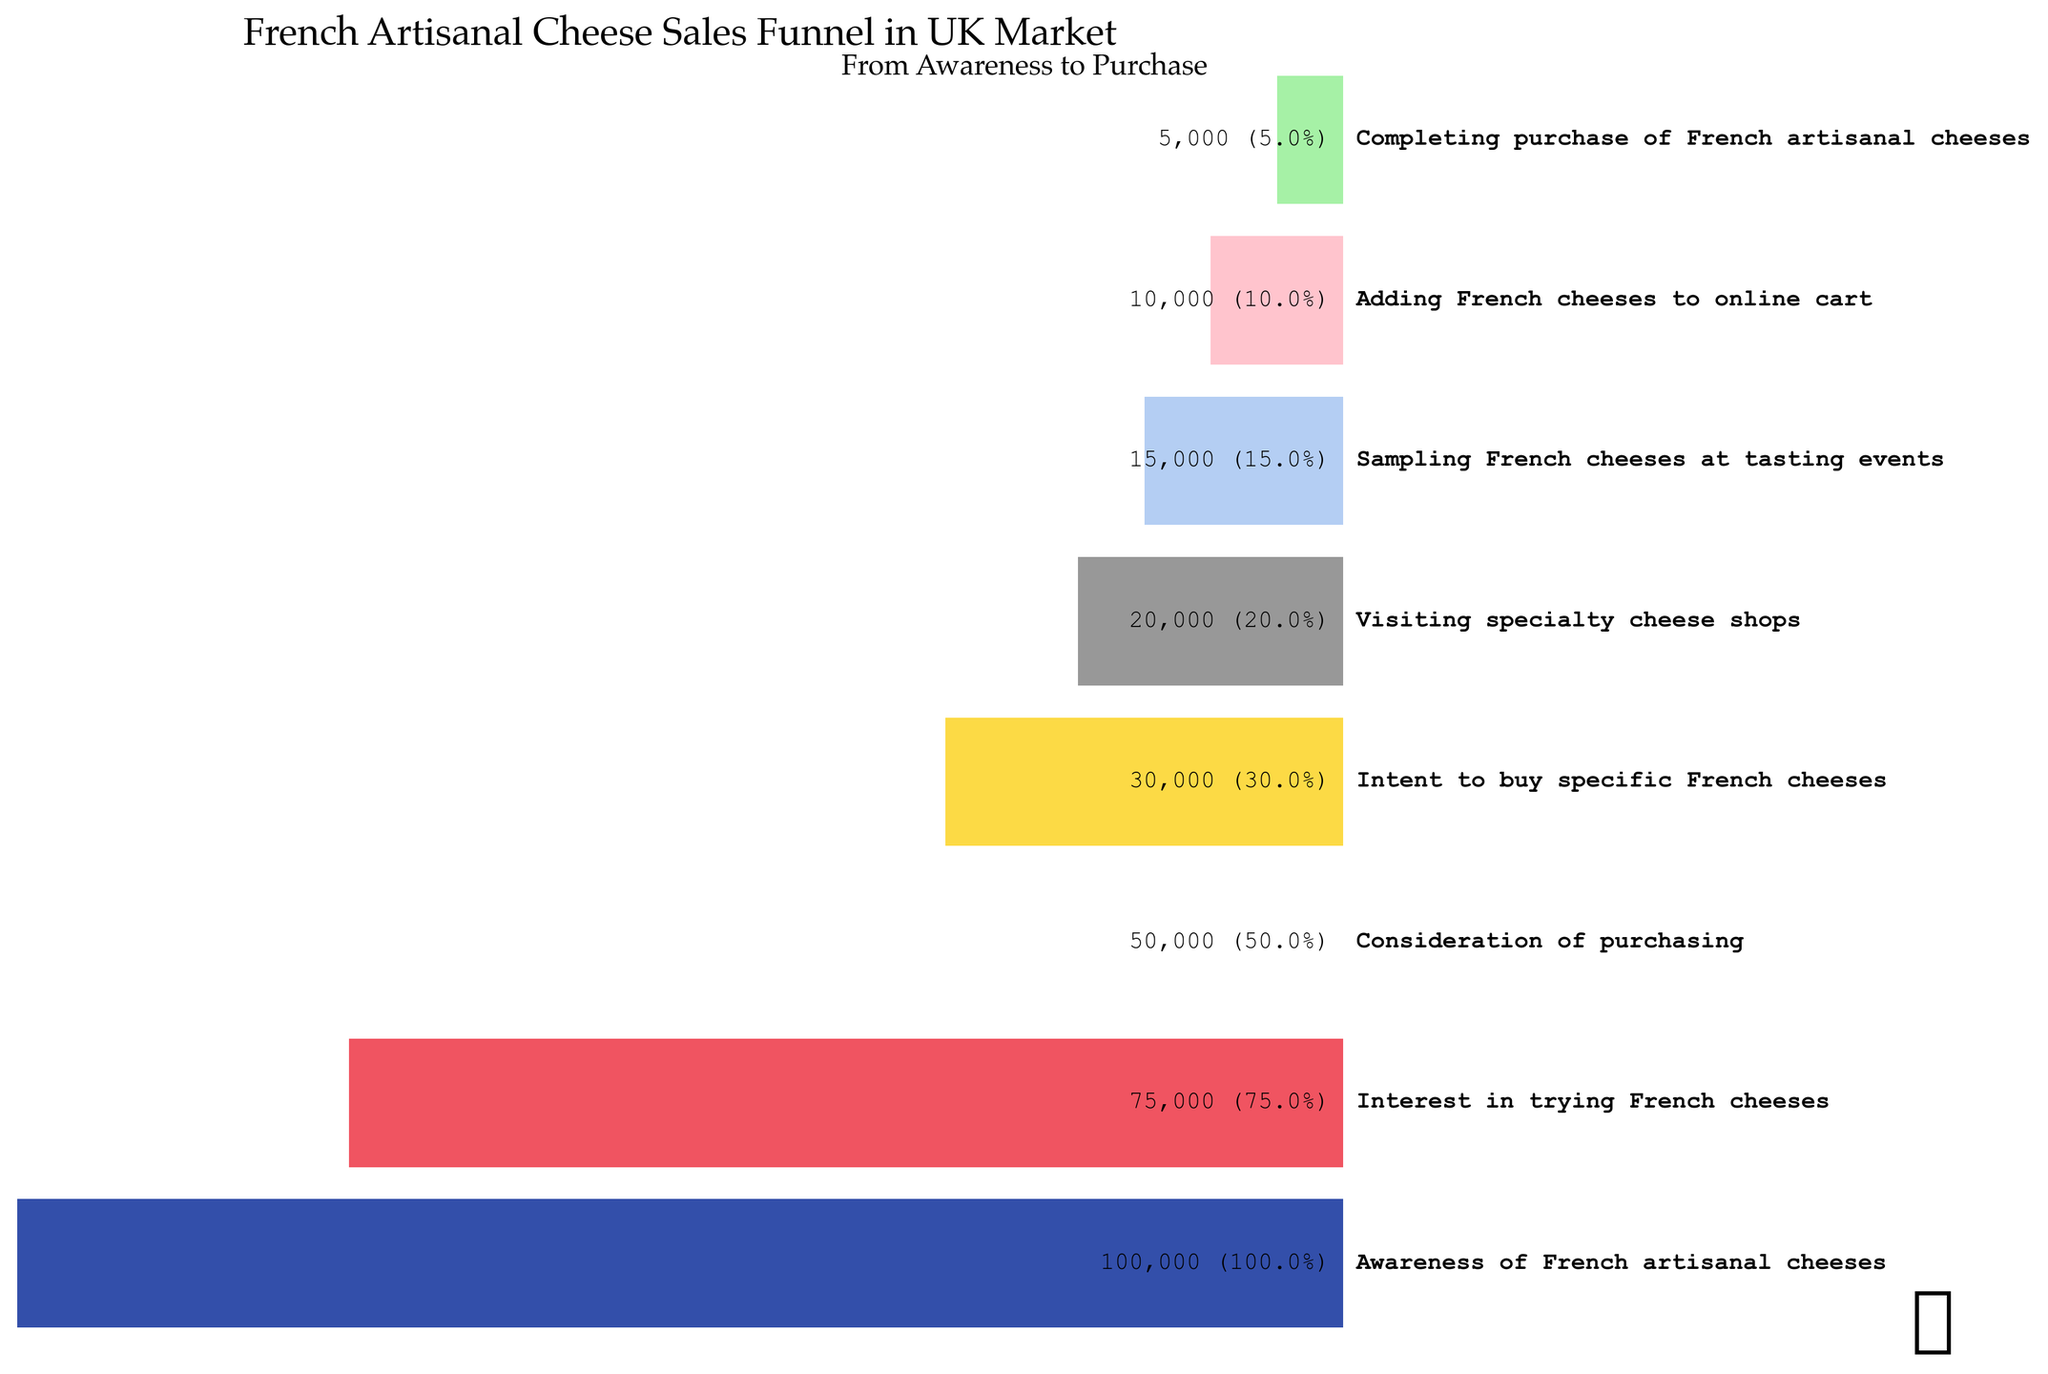What's the total number of people aware of French artisanal cheeses? The first stage of the funnel shows that 100,000 people are aware of French artisanal cheeses.
Answer: 100,000 What is the percentage drop in interest from awareness to consideration? The number of people aware of French artisanal cheeses is 100,000, and those considering a purchase are 50,000. The percentage drop is calculated as ((100,000 - 50,000) / 100,000) * 100 = 50%.
Answer: 50% Which stage sees the most significant reduction in the number of people compared to the previous stage? Comparing consecutive stages, the largest reduction occurs from "Intent to buy specific French cheeses" (30,000) to "Visiting specialty cheese shops" (20,000), a reduction of 10,000 people.
Answer: Intent to buy specific French cheeses to Visiting specialty cheese shops How many steps does it take for the number of people to reduce to 50% of those originally aware? The original number is 100,000. It takes three steps to reach 50,000, which is 50% of the original number. The relevant steps are: "Consideration of purchasing" has 50,000 people.
Answer: Three steps What is the final purchase conversion rate from awareness? The final purchase conversion rate is the number of people completing the purchase divided by the number of people aware. This is (5,000 / 100,000) * 100, which equals 5%.
Answer: 5% How many more people sample French cheeses at tasting events than those who add them to their online cart? There are 15,000 people sampling at tasting events and 10,000 adding to their cart. The difference is 15,000 - 10,000 = 5,000 people.
Answer: 5,000 Is the drop from "Visiting specialty cheese shops" to "Sampling French cheeses at tasting events" greater than the drop from "Sampling French cheeses at tasting events" to "Adding French cheeses to online cart"? The drop from visiting specialty cheese shops (20,000) to sampling at tasting events (15,000) is 5,000, whereas the drop from sampling at tasting events (15,000) to adding to the online cart (10,000) is also 5,000. Both drops are equal.
Answer: No At which stage does exactly one-third of the initial population remain? One-third of the initial population (100,000 people) is approximately 33,333. The nearest stage is "Intent to buy specific French cheeses," with 30,000 people, which is the closest to one-third.
Answer: Intent to buy specific French cheeses What percentage of people who consider purchasing French artisanal cheeses end up completing the purchase? The number of people considering purchasing is 50,000, and those completing the purchase is 5,000. The percentage is (5,000 / 50,000) * 100 = 10%.
Answer: 10% If 10 more stages were added to the funnel, would it be more informative for understanding consumer behavior? Explain. Adding more stages can provide more insights into specific points of dropout and consumer behavior nuances. However, the effectiveness depends on whether these stages help identify actionable points to improve conversion.
Answer: It depends on the detail and insight provided by the extra stages 